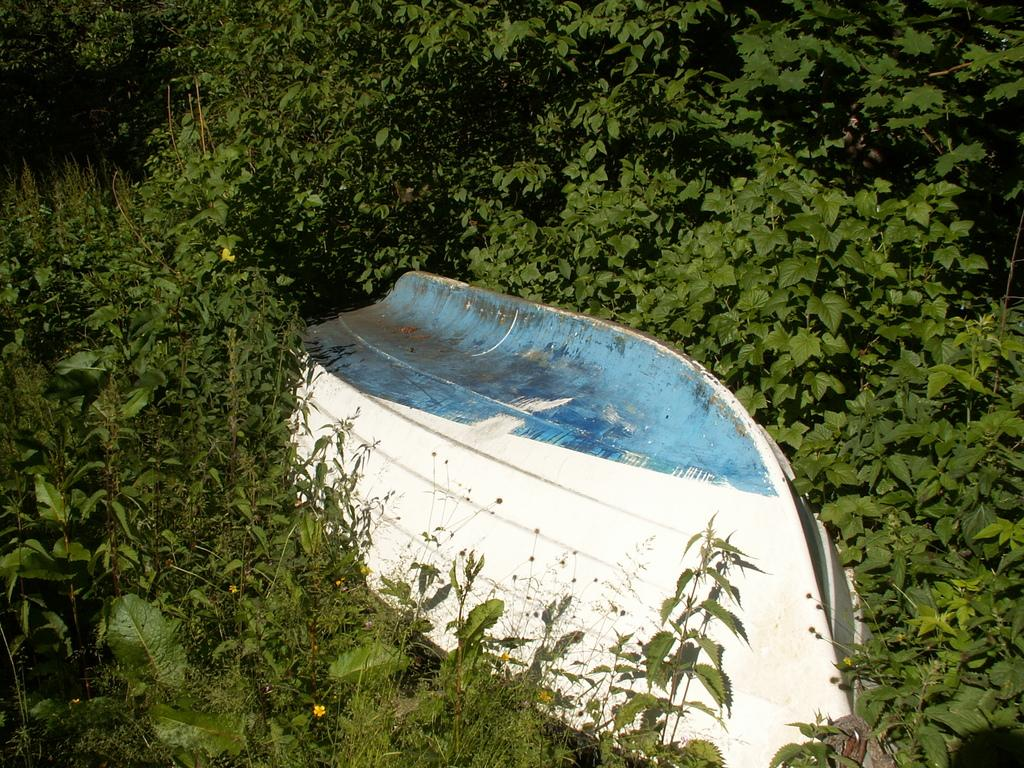What is the main subject in the middle of the image? There is a boat in the middle of the image. What can be seen in the background of the image? There is greenery in the background of the image. Where is the gate located in the image? There is no gate present in the image. What type of field can be seen in the image? There is no field present in the image; it features a boat and greenery in the background. 